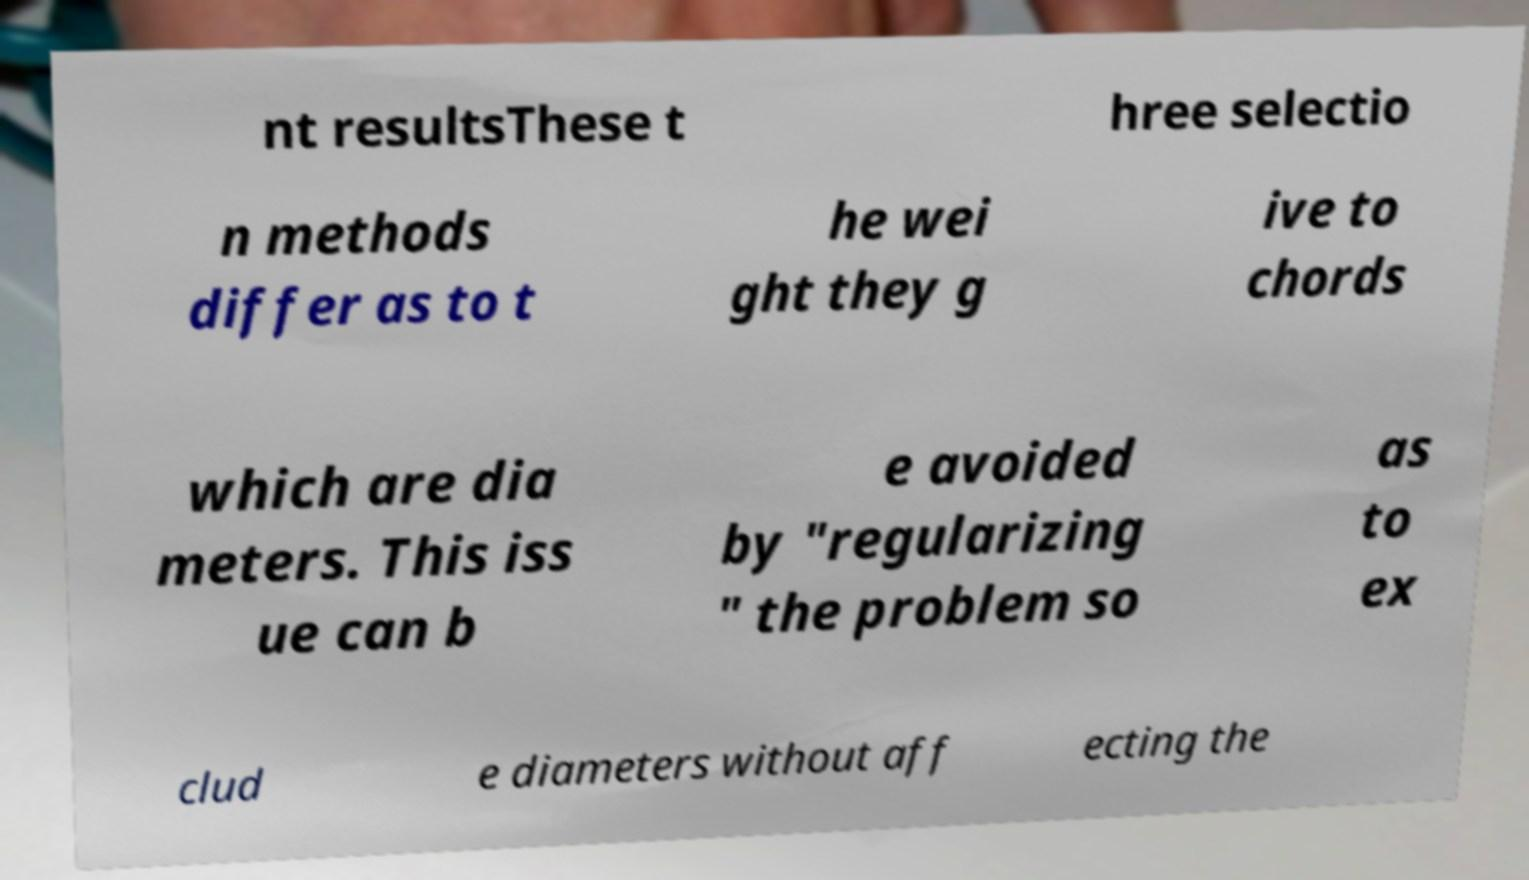Please read and relay the text visible in this image. What does it say? nt resultsThese t hree selectio n methods differ as to t he wei ght they g ive to chords which are dia meters. This iss ue can b e avoided by "regularizing " the problem so as to ex clud e diameters without aff ecting the 